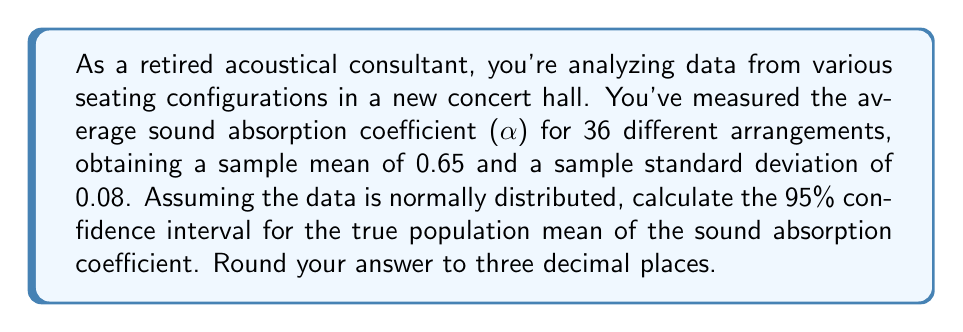Help me with this question. To calculate the confidence interval, we'll use the formula:

$$\text{CI} = \bar{x} \pm t_{\frac{\alpha}{2}, n-1} \cdot \frac{s}{\sqrt{n}}$$

Where:
$\bar{x}$ = sample mean = 0.65
$s$ = sample standard deviation = 0.08
$n$ = sample size = 36
$t_{\frac{\alpha}{2}, n-1}$ = t-value for 95% confidence level with 35 degrees of freedom

Steps:
1) For a 95% confidence interval, $\alpha = 0.05$
2) Degrees of freedom = $n - 1 = 36 - 1 = 35$
3) Look up $t_{0.025, 35}$ in a t-table or use a calculator. This value is approximately 2.030.
4) Calculate the margin of error:
   $$\text{ME} = t_{0.025, 35} \cdot \frac{s}{\sqrt{n}} = 2.030 \cdot \frac{0.08}{\sqrt{36}} = 2.030 \cdot 0.013333 = 0.027067$$
5) Calculate the confidence interval:
   $$\text{CI} = 0.65 \pm 0.027067$$
   $$\text{Lower bound} = 0.65 - 0.027067 = 0.622933$$
   $$\text{Upper bound} = 0.65 + 0.027067 = 0.677067$$
6) Round to three decimal places:
   $$\text{CI} = (0.623, 0.677)$$
Answer: The 95% confidence interval for the true population mean of the sound absorption coefficient is (0.623, 0.677). 